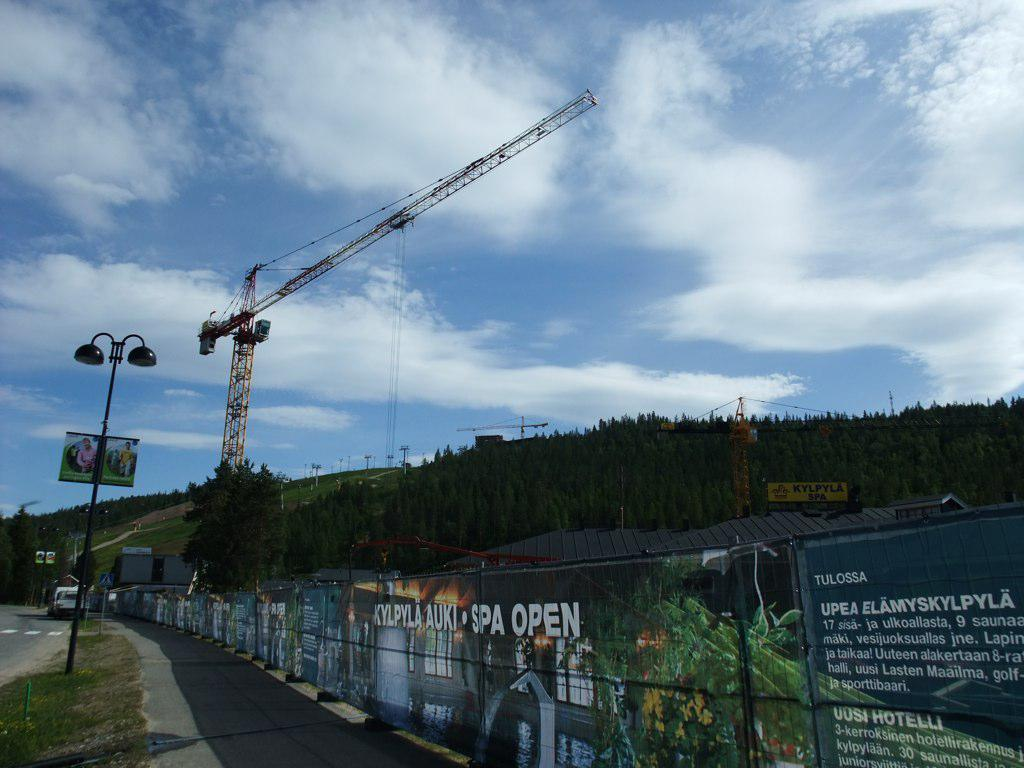What type of machinery is present in the image? There is a mobile crane in the image. What can be seen on the wall in the image? There are paintings on the wall in the image. What type of natural vegetation is visible in the image? There are trees visible in the image. What structure is present in the image? There is a pole in the image. What is visible in the sky at the top of the image? Clouds are visible in the sky at the top of the image. Where is the meeting taking place in the image? There is no meeting present in the image; it features a mobile crane, paintings, trees, a pole, and clouds in the sky. Can you tell me how many people are swimming in the image? There is no swimming or water visible in the image. 